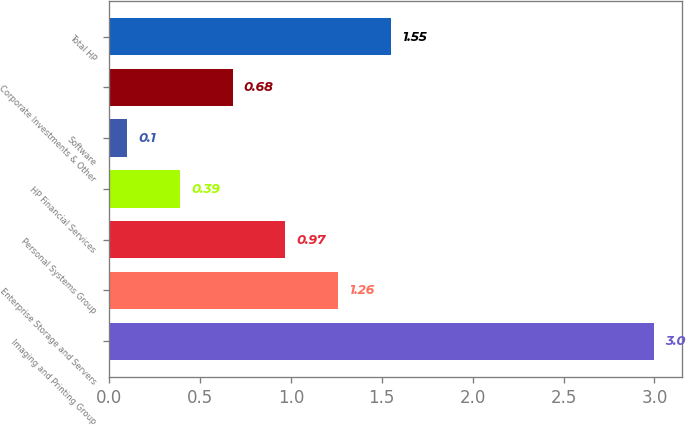<chart> <loc_0><loc_0><loc_500><loc_500><bar_chart><fcel>Imaging and Printing Group<fcel>Enterprise Storage and Servers<fcel>Personal Systems Group<fcel>HP Financial Services<fcel>Software<fcel>Corporate Investments & Other<fcel>Total HP<nl><fcel>3<fcel>1.26<fcel>0.97<fcel>0.39<fcel>0.1<fcel>0.68<fcel>1.55<nl></chart> 